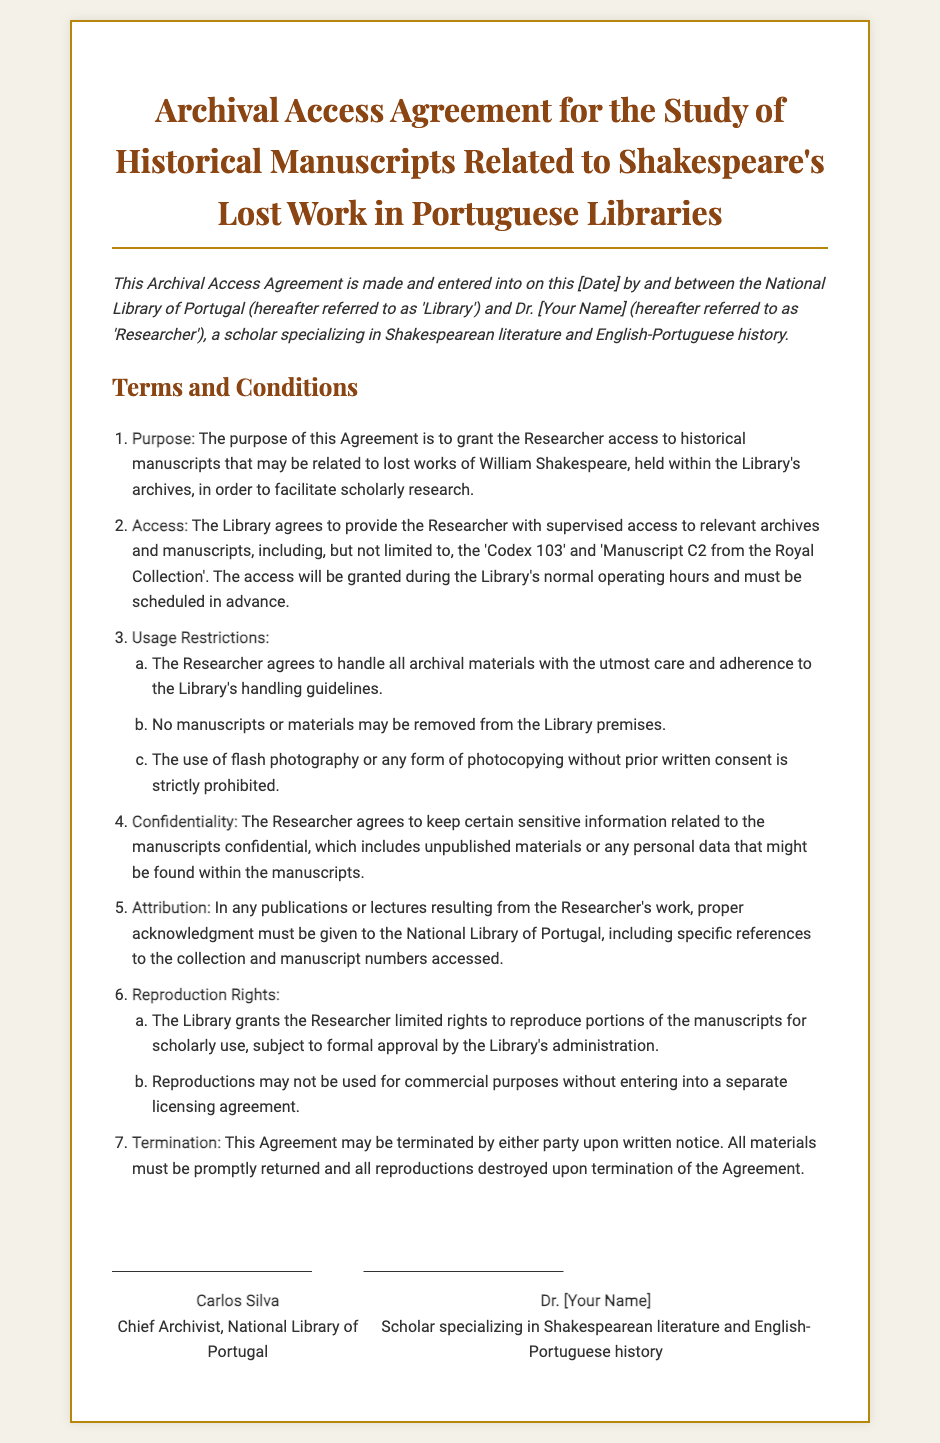what is the title of the document? The title is prominently displayed at the top of the contract, clearly stating the focus of the agreement.
Answer: Archival Access Agreement for the Study of Historical Manuscripts Related to Shakespeare's Lost Work in Portuguese Libraries who are the parties involved in the agreement? The parties are identified in the preamble of the contract, outlining the two main stakeholders involved.
Answer: National Library of Portugal and Dr. [Your Name] what is the purpose of the agreement? The purpose is specifically mentioned in the first term, clarifying the primary objective of granting access.
Answer: To grant the Researcher access to historical manuscripts what are the usage restrictions stated in the document? The usage restrictions are outlined in item 3 and listed in detail, highlighting specific prohibitions.
Answer: Handle with care, no removal, no photography without consent how can the agreement be terminated? The termination process is described in section 7, detailing the steps either party must follow to end the agreement.
Answer: Written notice what is required for reproduction of the manuscripts? The conditions for reproduction rights are provided in item 6, indicating the necessary approvals needed.
Answer: Limited rights subject to approval what must be returned upon termination? The termination clause specifies the items that need to be managed when the agreement is ended.
Answer: All materials what type of literature does the researcher specialize in? The area of expertise for the researcher is clearly stated, indicating the academic focus.
Answer: Shakespearean literature and English-Portuguese history who signs the agreement on behalf of the Library? The contract lists the individual responsible for signing on behalf of the Library.
Answer: Carlos Silva what must be included in publications resulting from the research? The attribution requirement is mentioned in term 5, indicating how the Library should be credited.
Answer: Proper acknowledgment must be given to the National Library of Portugal 